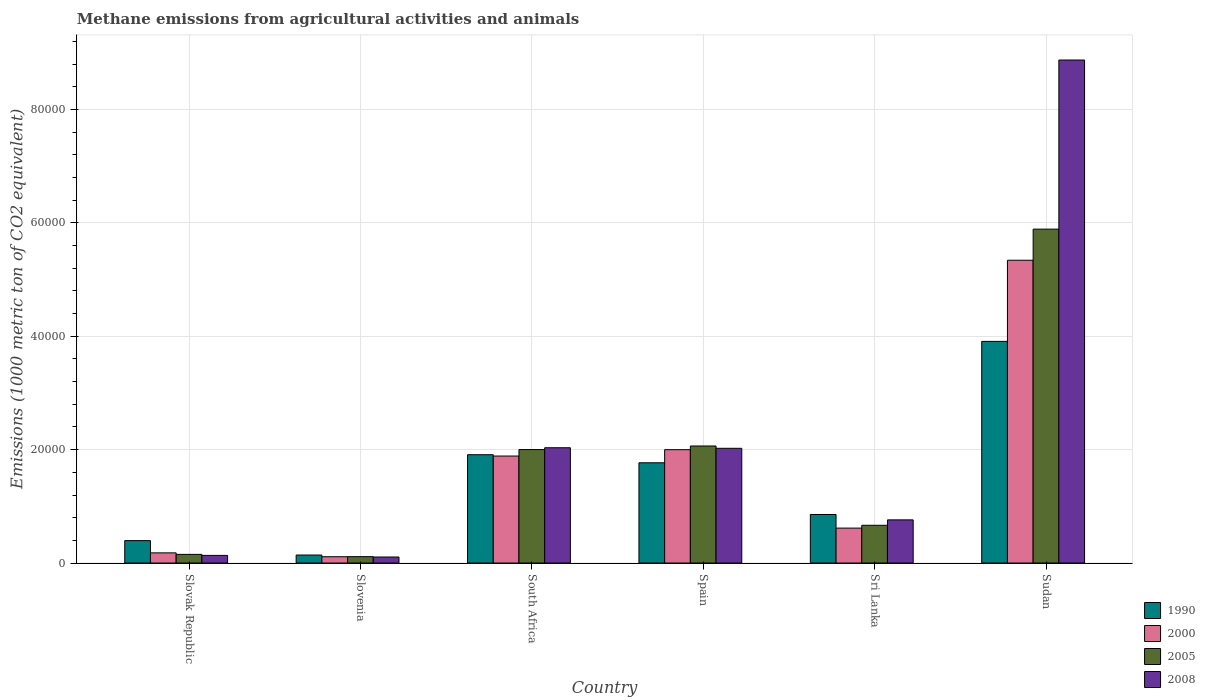Are the number of bars on each tick of the X-axis equal?
Give a very brief answer. Yes. What is the label of the 1st group of bars from the left?
Your answer should be compact. Slovak Republic. In how many cases, is the number of bars for a given country not equal to the number of legend labels?
Give a very brief answer. 0. What is the amount of methane emitted in 2005 in Slovak Republic?
Give a very brief answer. 1525.9. Across all countries, what is the maximum amount of methane emitted in 2005?
Ensure brevity in your answer.  5.89e+04. Across all countries, what is the minimum amount of methane emitted in 2005?
Your response must be concise. 1124.6. In which country was the amount of methane emitted in 2008 maximum?
Give a very brief answer. Sudan. In which country was the amount of methane emitted in 1990 minimum?
Your response must be concise. Slovenia. What is the total amount of methane emitted in 2005 in the graph?
Ensure brevity in your answer.  1.09e+05. What is the difference between the amount of methane emitted in 2000 in Sri Lanka and that in Sudan?
Your response must be concise. -4.73e+04. What is the difference between the amount of methane emitted in 2008 in Slovak Republic and the amount of methane emitted in 2005 in Spain?
Keep it short and to the point. -1.93e+04. What is the average amount of methane emitted in 2000 per country?
Your response must be concise. 1.69e+04. What is the difference between the amount of methane emitted of/in 1990 and amount of methane emitted of/in 2005 in Slovenia?
Provide a succinct answer. 288.9. What is the ratio of the amount of methane emitted in 1990 in Slovak Republic to that in Spain?
Your answer should be very brief. 0.22. Is the amount of methane emitted in 2005 in South Africa less than that in Sudan?
Keep it short and to the point. Yes. What is the difference between the highest and the second highest amount of methane emitted in 2008?
Offer a terse response. 99.4. What is the difference between the highest and the lowest amount of methane emitted in 2008?
Offer a terse response. 8.77e+04. Is it the case that in every country, the sum of the amount of methane emitted in 1990 and amount of methane emitted in 2000 is greater than the sum of amount of methane emitted in 2005 and amount of methane emitted in 2008?
Make the answer very short. No. How many bars are there?
Offer a terse response. 24. Are all the bars in the graph horizontal?
Ensure brevity in your answer.  No. Does the graph contain any zero values?
Provide a short and direct response. No. Does the graph contain grids?
Offer a terse response. Yes. How many legend labels are there?
Give a very brief answer. 4. What is the title of the graph?
Ensure brevity in your answer.  Methane emissions from agricultural activities and animals. What is the label or title of the X-axis?
Provide a succinct answer. Country. What is the label or title of the Y-axis?
Make the answer very short. Emissions (1000 metric ton of CO2 equivalent). What is the Emissions (1000 metric ton of CO2 equivalent) of 1990 in Slovak Republic?
Give a very brief answer. 3954.5. What is the Emissions (1000 metric ton of CO2 equivalent) in 2000 in Slovak Republic?
Offer a terse response. 1793.2. What is the Emissions (1000 metric ton of CO2 equivalent) in 2005 in Slovak Republic?
Your response must be concise. 1525.9. What is the Emissions (1000 metric ton of CO2 equivalent) in 2008 in Slovak Republic?
Offer a terse response. 1345.7. What is the Emissions (1000 metric ton of CO2 equivalent) of 1990 in Slovenia?
Your answer should be very brief. 1413.5. What is the Emissions (1000 metric ton of CO2 equivalent) of 2000 in Slovenia?
Your response must be concise. 1111. What is the Emissions (1000 metric ton of CO2 equivalent) of 2005 in Slovenia?
Make the answer very short. 1124.6. What is the Emissions (1000 metric ton of CO2 equivalent) in 2008 in Slovenia?
Give a very brief answer. 1061.8. What is the Emissions (1000 metric ton of CO2 equivalent) of 1990 in South Africa?
Keep it short and to the point. 1.91e+04. What is the Emissions (1000 metric ton of CO2 equivalent) of 2000 in South Africa?
Your answer should be compact. 1.89e+04. What is the Emissions (1000 metric ton of CO2 equivalent) of 2005 in South Africa?
Make the answer very short. 2.00e+04. What is the Emissions (1000 metric ton of CO2 equivalent) in 2008 in South Africa?
Your response must be concise. 2.03e+04. What is the Emissions (1000 metric ton of CO2 equivalent) in 1990 in Spain?
Offer a very short reply. 1.77e+04. What is the Emissions (1000 metric ton of CO2 equivalent) of 2000 in Spain?
Make the answer very short. 2.00e+04. What is the Emissions (1000 metric ton of CO2 equivalent) of 2005 in Spain?
Your response must be concise. 2.06e+04. What is the Emissions (1000 metric ton of CO2 equivalent) in 2008 in Spain?
Make the answer very short. 2.02e+04. What is the Emissions (1000 metric ton of CO2 equivalent) of 1990 in Sri Lanka?
Keep it short and to the point. 8565.4. What is the Emissions (1000 metric ton of CO2 equivalent) in 2000 in Sri Lanka?
Offer a terse response. 6161. What is the Emissions (1000 metric ton of CO2 equivalent) of 2005 in Sri Lanka?
Your answer should be very brief. 6658.4. What is the Emissions (1000 metric ton of CO2 equivalent) of 2008 in Sri Lanka?
Your response must be concise. 7614.5. What is the Emissions (1000 metric ton of CO2 equivalent) in 1990 in Sudan?
Your answer should be compact. 3.91e+04. What is the Emissions (1000 metric ton of CO2 equivalent) in 2000 in Sudan?
Provide a succinct answer. 5.34e+04. What is the Emissions (1000 metric ton of CO2 equivalent) in 2005 in Sudan?
Offer a very short reply. 5.89e+04. What is the Emissions (1000 metric ton of CO2 equivalent) in 2008 in Sudan?
Ensure brevity in your answer.  8.87e+04. Across all countries, what is the maximum Emissions (1000 metric ton of CO2 equivalent) of 1990?
Provide a succinct answer. 3.91e+04. Across all countries, what is the maximum Emissions (1000 metric ton of CO2 equivalent) in 2000?
Give a very brief answer. 5.34e+04. Across all countries, what is the maximum Emissions (1000 metric ton of CO2 equivalent) of 2005?
Provide a short and direct response. 5.89e+04. Across all countries, what is the maximum Emissions (1000 metric ton of CO2 equivalent) in 2008?
Provide a succinct answer. 8.87e+04. Across all countries, what is the minimum Emissions (1000 metric ton of CO2 equivalent) of 1990?
Offer a very short reply. 1413.5. Across all countries, what is the minimum Emissions (1000 metric ton of CO2 equivalent) of 2000?
Your answer should be very brief. 1111. Across all countries, what is the minimum Emissions (1000 metric ton of CO2 equivalent) in 2005?
Give a very brief answer. 1124.6. Across all countries, what is the minimum Emissions (1000 metric ton of CO2 equivalent) in 2008?
Your answer should be compact. 1061.8. What is the total Emissions (1000 metric ton of CO2 equivalent) of 1990 in the graph?
Provide a short and direct response. 8.98e+04. What is the total Emissions (1000 metric ton of CO2 equivalent) of 2000 in the graph?
Your answer should be very brief. 1.01e+05. What is the total Emissions (1000 metric ton of CO2 equivalent) of 2005 in the graph?
Ensure brevity in your answer.  1.09e+05. What is the total Emissions (1000 metric ton of CO2 equivalent) in 2008 in the graph?
Your answer should be very brief. 1.39e+05. What is the difference between the Emissions (1000 metric ton of CO2 equivalent) of 1990 in Slovak Republic and that in Slovenia?
Your response must be concise. 2541. What is the difference between the Emissions (1000 metric ton of CO2 equivalent) of 2000 in Slovak Republic and that in Slovenia?
Your response must be concise. 682.2. What is the difference between the Emissions (1000 metric ton of CO2 equivalent) in 2005 in Slovak Republic and that in Slovenia?
Offer a terse response. 401.3. What is the difference between the Emissions (1000 metric ton of CO2 equivalent) of 2008 in Slovak Republic and that in Slovenia?
Your answer should be compact. 283.9. What is the difference between the Emissions (1000 metric ton of CO2 equivalent) of 1990 in Slovak Republic and that in South Africa?
Provide a succinct answer. -1.52e+04. What is the difference between the Emissions (1000 metric ton of CO2 equivalent) of 2000 in Slovak Republic and that in South Africa?
Your answer should be compact. -1.71e+04. What is the difference between the Emissions (1000 metric ton of CO2 equivalent) of 2005 in Slovak Republic and that in South Africa?
Provide a succinct answer. -1.85e+04. What is the difference between the Emissions (1000 metric ton of CO2 equivalent) in 2008 in Slovak Republic and that in South Africa?
Keep it short and to the point. -1.90e+04. What is the difference between the Emissions (1000 metric ton of CO2 equivalent) in 1990 in Slovak Republic and that in Spain?
Your answer should be compact. -1.37e+04. What is the difference between the Emissions (1000 metric ton of CO2 equivalent) in 2000 in Slovak Republic and that in Spain?
Provide a succinct answer. -1.82e+04. What is the difference between the Emissions (1000 metric ton of CO2 equivalent) in 2005 in Slovak Republic and that in Spain?
Keep it short and to the point. -1.91e+04. What is the difference between the Emissions (1000 metric ton of CO2 equivalent) of 2008 in Slovak Republic and that in Spain?
Make the answer very short. -1.89e+04. What is the difference between the Emissions (1000 metric ton of CO2 equivalent) in 1990 in Slovak Republic and that in Sri Lanka?
Offer a very short reply. -4610.9. What is the difference between the Emissions (1000 metric ton of CO2 equivalent) of 2000 in Slovak Republic and that in Sri Lanka?
Give a very brief answer. -4367.8. What is the difference between the Emissions (1000 metric ton of CO2 equivalent) in 2005 in Slovak Republic and that in Sri Lanka?
Give a very brief answer. -5132.5. What is the difference between the Emissions (1000 metric ton of CO2 equivalent) in 2008 in Slovak Republic and that in Sri Lanka?
Your response must be concise. -6268.8. What is the difference between the Emissions (1000 metric ton of CO2 equivalent) of 1990 in Slovak Republic and that in Sudan?
Provide a short and direct response. -3.51e+04. What is the difference between the Emissions (1000 metric ton of CO2 equivalent) of 2000 in Slovak Republic and that in Sudan?
Your response must be concise. -5.16e+04. What is the difference between the Emissions (1000 metric ton of CO2 equivalent) in 2005 in Slovak Republic and that in Sudan?
Provide a short and direct response. -5.74e+04. What is the difference between the Emissions (1000 metric ton of CO2 equivalent) of 2008 in Slovak Republic and that in Sudan?
Give a very brief answer. -8.74e+04. What is the difference between the Emissions (1000 metric ton of CO2 equivalent) in 1990 in Slovenia and that in South Africa?
Keep it short and to the point. -1.77e+04. What is the difference between the Emissions (1000 metric ton of CO2 equivalent) of 2000 in Slovenia and that in South Africa?
Provide a succinct answer. -1.78e+04. What is the difference between the Emissions (1000 metric ton of CO2 equivalent) of 2005 in Slovenia and that in South Africa?
Provide a short and direct response. -1.89e+04. What is the difference between the Emissions (1000 metric ton of CO2 equivalent) in 2008 in Slovenia and that in South Africa?
Give a very brief answer. -1.93e+04. What is the difference between the Emissions (1000 metric ton of CO2 equivalent) of 1990 in Slovenia and that in Spain?
Provide a succinct answer. -1.63e+04. What is the difference between the Emissions (1000 metric ton of CO2 equivalent) of 2000 in Slovenia and that in Spain?
Make the answer very short. -1.89e+04. What is the difference between the Emissions (1000 metric ton of CO2 equivalent) of 2005 in Slovenia and that in Spain?
Make the answer very short. -1.95e+04. What is the difference between the Emissions (1000 metric ton of CO2 equivalent) in 2008 in Slovenia and that in Spain?
Give a very brief answer. -1.92e+04. What is the difference between the Emissions (1000 metric ton of CO2 equivalent) of 1990 in Slovenia and that in Sri Lanka?
Your answer should be compact. -7151.9. What is the difference between the Emissions (1000 metric ton of CO2 equivalent) of 2000 in Slovenia and that in Sri Lanka?
Give a very brief answer. -5050. What is the difference between the Emissions (1000 metric ton of CO2 equivalent) of 2005 in Slovenia and that in Sri Lanka?
Make the answer very short. -5533.8. What is the difference between the Emissions (1000 metric ton of CO2 equivalent) in 2008 in Slovenia and that in Sri Lanka?
Ensure brevity in your answer.  -6552.7. What is the difference between the Emissions (1000 metric ton of CO2 equivalent) of 1990 in Slovenia and that in Sudan?
Ensure brevity in your answer.  -3.77e+04. What is the difference between the Emissions (1000 metric ton of CO2 equivalent) of 2000 in Slovenia and that in Sudan?
Keep it short and to the point. -5.23e+04. What is the difference between the Emissions (1000 metric ton of CO2 equivalent) in 2005 in Slovenia and that in Sudan?
Your answer should be very brief. -5.78e+04. What is the difference between the Emissions (1000 metric ton of CO2 equivalent) in 2008 in Slovenia and that in Sudan?
Make the answer very short. -8.77e+04. What is the difference between the Emissions (1000 metric ton of CO2 equivalent) in 1990 in South Africa and that in Spain?
Keep it short and to the point. 1425.6. What is the difference between the Emissions (1000 metric ton of CO2 equivalent) in 2000 in South Africa and that in Spain?
Provide a short and direct response. -1123.1. What is the difference between the Emissions (1000 metric ton of CO2 equivalent) of 2005 in South Africa and that in Spain?
Give a very brief answer. -632.9. What is the difference between the Emissions (1000 metric ton of CO2 equivalent) in 2008 in South Africa and that in Spain?
Your answer should be compact. 99.4. What is the difference between the Emissions (1000 metric ton of CO2 equivalent) of 1990 in South Africa and that in Sri Lanka?
Ensure brevity in your answer.  1.05e+04. What is the difference between the Emissions (1000 metric ton of CO2 equivalent) in 2000 in South Africa and that in Sri Lanka?
Offer a very short reply. 1.27e+04. What is the difference between the Emissions (1000 metric ton of CO2 equivalent) in 2005 in South Africa and that in Sri Lanka?
Offer a terse response. 1.34e+04. What is the difference between the Emissions (1000 metric ton of CO2 equivalent) in 2008 in South Africa and that in Sri Lanka?
Make the answer very short. 1.27e+04. What is the difference between the Emissions (1000 metric ton of CO2 equivalent) in 1990 in South Africa and that in Sudan?
Keep it short and to the point. -2.00e+04. What is the difference between the Emissions (1000 metric ton of CO2 equivalent) of 2000 in South Africa and that in Sudan?
Offer a terse response. -3.45e+04. What is the difference between the Emissions (1000 metric ton of CO2 equivalent) of 2005 in South Africa and that in Sudan?
Provide a succinct answer. -3.89e+04. What is the difference between the Emissions (1000 metric ton of CO2 equivalent) of 2008 in South Africa and that in Sudan?
Make the answer very short. -6.84e+04. What is the difference between the Emissions (1000 metric ton of CO2 equivalent) in 1990 in Spain and that in Sri Lanka?
Make the answer very short. 9117.2. What is the difference between the Emissions (1000 metric ton of CO2 equivalent) of 2000 in Spain and that in Sri Lanka?
Your response must be concise. 1.38e+04. What is the difference between the Emissions (1000 metric ton of CO2 equivalent) in 2005 in Spain and that in Sri Lanka?
Your response must be concise. 1.40e+04. What is the difference between the Emissions (1000 metric ton of CO2 equivalent) of 2008 in Spain and that in Sri Lanka?
Provide a short and direct response. 1.26e+04. What is the difference between the Emissions (1000 metric ton of CO2 equivalent) of 1990 in Spain and that in Sudan?
Make the answer very short. -2.14e+04. What is the difference between the Emissions (1000 metric ton of CO2 equivalent) in 2000 in Spain and that in Sudan?
Keep it short and to the point. -3.34e+04. What is the difference between the Emissions (1000 metric ton of CO2 equivalent) of 2005 in Spain and that in Sudan?
Provide a succinct answer. -3.83e+04. What is the difference between the Emissions (1000 metric ton of CO2 equivalent) in 2008 in Spain and that in Sudan?
Make the answer very short. -6.85e+04. What is the difference between the Emissions (1000 metric ton of CO2 equivalent) in 1990 in Sri Lanka and that in Sudan?
Your answer should be very brief. -3.05e+04. What is the difference between the Emissions (1000 metric ton of CO2 equivalent) of 2000 in Sri Lanka and that in Sudan?
Your answer should be very brief. -4.73e+04. What is the difference between the Emissions (1000 metric ton of CO2 equivalent) of 2005 in Sri Lanka and that in Sudan?
Your answer should be compact. -5.22e+04. What is the difference between the Emissions (1000 metric ton of CO2 equivalent) of 2008 in Sri Lanka and that in Sudan?
Provide a succinct answer. -8.11e+04. What is the difference between the Emissions (1000 metric ton of CO2 equivalent) of 1990 in Slovak Republic and the Emissions (1000 metric ton of CO2 equivalent) of 2000 in Slovenia?
Make the answer very short. 2843.5. What is the difference between the Emissions (1000 metric ton of CO2 equivalent) of 1990 in Slovak Republic and the Emissions (1000 metric ton of CO2 equivalent) of 2005 in Slovenia?
Give a very brief answer. 2829.9. What is the difference between the Emissions (1000 metric ton of CO2 equivalent) in 1990 in Slovak Republic and the Emissions (1000 metric ton of CO2 equivalent) in 2008 in Slovenia?
Make the answer very short. 2892.7. What is the difference between the Emissions (1000 metric ton of CO2 equivalent) in 2000 in Slovak Republic and the Emissions (1000 metric ton of CO2 equivalent) in 2005 in Slovenia?
Make the answer very short. 668.6. What is the difference between the Emissions (1000 metric ton of CO2 equivalent) in 2000 in Slovak Republic and the Emissions (1000 metric ton of CO2 equivalent) in 2008 in Slovenia?
Offer a terse response. 731.4. What is the difference between the Emissions (1000 metric ton of CO2 equivalent) of 2005 in Slovak Republic and the Emissions (1000 metric ton of CO2 equivalent) of 2008 in Slovenia?
Make the answer very short. 464.1. What is the difference between the Emissions (1000 metric ton of CO2 equivalent) of 1990 in Slovak Republic and the Emissions (1000 metric ton of CO2 equivalent) of 2000 in South Africa?
Your response must be concise. -1.49e+04. What is the difference between the Emissions (1000 metric ton of CO2 equivalent) of 1990 in Slovak Republic and the Emissions (1000 metric ton of CO2 equivalent) of 2005 in South Africa?
Provide a short and direct response. -1.61e+04. What is the difference between the Emissions (1000 metric ton of CO2 equivalent) of 1990 in Slovak Republic and the Emissions (1000 metric ton of CO2 equivalent) of 2008 in South Africa?
Give a very brief answer. -1.64e+04. What is the difference between the Emissions (1000 metric ton of CO2 equivalent) of 2000 in Slovak Republic and the Emissions (1000 metric ton of CO2 equivalent) of 2005 in South Africa?
Your response must be concise. -1.82e+04. What is the difference between the Emissions (1000 metric ton of CO2 equivalent) in 2000 in Slovak Republic and the Emissions (1000 metric ton of CO2 equivalent) in 2008 in South Africa?
Make the answer very short. -1.85e+04. What is the difference between the Emissions (1000 metric ton of CO2 equivalent) in 2005 in Slovak Republic and the Emissions (1000 metric ton of CO2 equivalent) in 2008 in South Africa?
Provide a succinct answer. -1.88e+04. What is the difference between the Emissions (1000 metric ton of CO2 equivalent) in 1990 in Slovak Republic and the Emissions (1000 metric ton of CO2 equivalent) in 2000 in Spain?
Provide a succinct answer. -1.60e+04. What is the difference between the Emissions (1000 metric ton of CO2 equivalent) of 1990 in Slovak Republic and the Emissions (1000 metric ton of CO2 equivalent) of 2005 in Spain?
Provide a short and direct response. -1.67e+04. What is the difference between the Emissions (1000 metric ton of CO2 equivalent) of 1990 in Slovak Republic and the Emissions (1000 metric ton of CO2 equivalent) of 2008 in Spain?
Your answer should be compact. -1.63e+04. What is the difference between the Emissions (1000 metric ton of CO2 equivalent) in 2000 in Slovak Republic and the Emissions (1000 metric ton of CO2 equivalent) in 2005 in Spain?
Your response must be concise. -1.89e+04. What is the difference between the Emissions (1000 metric ton of CO2 equivalent) of 2000 in Slovak Republic and the Emissions (1000 metric ton of CO2 equivalent) of 2008 in Spain?
Your answer should be compact. -1.84e+04. What is the difference between the Emissions (1000 metric ton of CO2 equivalent) of 2005 in Slovak Republic and the Emissions (1000 metric ton of CO2 equivalent) of 2008 in Spain?
Provide a short and direct response. -1.87e+04. What is the difference between the Emissions (1000 metric ton of CO2 equivalent) of 1990 in Slovak Republic and the Emissions (1000 metric ton of CO2 equivalent) of 2000 in Sri Lanka?
Offer a very short reply. -2206.5. What is the difference between the Emissions (1000 metric ton of CO2 equivalent) in 1990 in Slovak Republic and the Emissions (1000 metric ton of CO2 equivalent) in 2005 in Sri Lanka?
Offer a terse response. -2703.9. What is the difference between the Emissions (1000 metric ton of CO2 equivalent) of 1990 in Slovak Republic and the Emissions (1000 metric ton of CO2 equivalent) of 2008 in Sri Lanka?
Your response must be concise. -3660. What is the difference between the Emissions (1000 metric ton of CO2 equivalent) of 2000 in Slovak Republic and the Emissions (1000 metric ton of CO2 equivalent) of 2005 in Sri Lanka?
Provide a succinct answer. -4865.2. What is the difference between the Emissions (1000 metric ton of CO2 equivalent) of 2000 in Slovak Republic and the Emissions (1000 metric ton of CO2 equivalent) of 2008 in Sri Lanka?
Provide a short and direct response. -5821.3. What is the difference between the Emissions (1000 metric ton of CO2 equivalent) in 2005 in Slovak Republic and the Emissions (1000 metric ton of CO2 equivalent) in 2008 in Sri Lanka?
Offer a terse response. -6088.6. What is the difference between the Emissions (1000 metric ton of CO2 equivalent) of 1990 in Slovak Republic and the Emissions (1000 metric ton of CO2 equivalent) of 2000 in Sudan?
Give a very brief answer. -4.95e+04. What is the difference between the Emissions (1000 metric ton of CO2 equivalent) of 1990 in Slovak Republic and the Emissions (1000 metric ton of CO2 equivalent) of 2005 in Sudan?
Provide a succinct answer. -5.49e+04. What is the difference between the Emissions (1000 metric ton of CO2 equivalent) of 1990 in Slovak Republic and the Emissions (1000 metric ton of CO2 equivalent) of 2008 in Sudan?
Your response must be concise. -8.48e+04. What is the difference between the Emissions (1000 metric ton of CO2 equivalent) in 2000 in Slovak Republic and the Emissions (1000 metric ton of CO2 equivalent) in 2005 in Sudan?
Your response must be concise. -5.71e+04. What is the difference between the Emissions (1000 metric ton of CO2 equivalent) of 2000 in Slovak Republic and the Emissions (1000 metric ton of CO2 equivalent) of 2008 in Sudan?
Keep it short and to the point. -8.69e+04. What is the difference between the Emissions (1000 metric ton of CO2 equivalent) of 2005 in Slovak Republic and the Emissions (1000 metric ton of CO2 equivalent) of 2008 in Sudan?
Keep it short and to the point. -8.72e+04. What is the difference between the Emissions (1000 metric ton of CO2 equivalent) of 1990 in Slovenia and the Emissions (1000 metric ton of CO2 equivalent) of 2000 in South Africa?
Provide a succinct answer. -1.75e+04. What is the difference between the Emissions (1000 metric ton of CO2 equivalent) in 1990 in Slovenia and the Emissions (1000 metric ton of CO2 equivalent) in 2005 in South Africa?
Your answer should be compact. -1.86e+04. What is the difference between the Emissions (1000 metric ton of CO2 equivalent) of 1990 in Slovenia and the Emissions (1000 metric ton of CO2 equivalent) of 2008 in South Africa?
Your answer should be compact. -1.89e+04. What is the difference between the Emissions (1000 metric ton of CO2 equivalent) of 2000 in Slovenia and the Emissions (1000 metric ton of CO2 equivalent) of 2005 in South Africa?
Your answer should be very brief. -1.89e+04. What is the difference between the Emissions (1000 metric ton of CO2 equivalent) in 2000 in Slovenia and the Emissions (1000 metric ton of CO2 equivalent) in 2008 in South Africa?
Your answer should be compact. -1.92e+04. What is the difference between the Emissions (1000 metric ton of CO2 equivalent) of 2005 in Slovenia and the Emissions (1000 metric ton of CO2 equivalent) of 2008 in South Africa?
Give a very brief answer. -1.92e+04. What is the difference between the Emissions (1000 metric ton of CO2 equivalent) in 1990 in Slovenia and the Emissions (1000 metric ton of CO2 equivalent) in 2000 in Spain?
Ensure brevity in your answer.  -1.86e+04. What is the difference between the Emissions (1000 metric ton of CO2 equivalent) of 1990 in Slovenia and the Emissions (1000 metric ton of CO2 equivalent) of 2005 in Spain?
Your response must be concise. -1.92e+04. What is the difference between the Emissions (1000 metric ton of CO2 equivalent) in 1990 in Slovenia and the Emissions (1000 metric ton of CO2 equivalent) in 2008 in Spain?
Keep it short and to the point. -1.88e+04. What is the difference between the Emissions (1000 metric ton of CO2 equivalent) of 2000 in Slovenia and the Emissions (1000 metric ton of CO2 equivalent) of 2005 in Spain?
Provide a short and direct response. -1.95e+04. What is the difference between the Emissions (1000 metric ton of CO2 equivalent) in 2000 in Slovenia and the Emissions (1000 metric ton of CO2 equivalent) in 2008 in Spain?
Provide a short and direct response. -1.91e+04. What is the difference between the Emissions (1000 metric ton of CO2 equivalent) of 2005 in Slovenia and the Emissions (1000 metric ton of CO2 equivalent) of 2008 in Spain?
Your answer should be compact. -1.91e+04. What is the difference between the Emissions (1000 metric ton of CO2 equivalent) in 1990 in Slovenia and the Emissions (1000 metric ton of CO2 equivalent) in 2000 in Sri Lanka?
Your response must be concise. -4747.5. What is the difference between the Emissions (1000 metric ton of CO2 equivalent) of 1990 in Slovenia and the Emissions (1000 metric ton of CO2 equivalent) of 2005 in Sri Lanka?
Offer a very short reply. -5244.9. What is the difference between the Emissions (1000 metric ton of CO2 equivalent) of 1990 in Slovenia and the Emissions (1000 metric ton of CO2 equivalent) of 2008 in Sri Lanka?
Make the answer very short. -6201. What is the difference between the Emissions (1000 metric ton of CO2 equivalent) of 2000 in Slovenia and the Emissions (1000 metric ton of CO2 equivalent) of 2005 in Sri Lanka?
Offer a very short reply. -5547.4. What is the difference between the Emissions (1000 metric ton of CO2 equivalent) in 2000 in Slovenia and the Emissions (1000 metric ton of CO2 equivalent) in 2008 in Sri Lanka?
Offer a terse response. -6503.5. What is the difference between the Emissions (1000 metric ton of CO2 equivalent) in 2005 in Slovenia and the Emissions (1000 metric ton of CO2 equivalent) in 2008 in Sri Lanka?
Offer a very short reply. -6489.9. What is the difference between the Emissions (1000 metric ton of CO2 equivalent) in 1990 in Slovenia and the Emissions (1000 metric ton of CO2 equivalent) in 2000 in Sudan?
Your response must be concise. -5.20e+04. What is the difference between the Emissions (1000 metric ton of CO2 equivalent) in 1990 in Slovenia and the Emissions (1000 metric ton of CO2 equivalent) in 2005 in Sudan?
Offer a terse response. -5.75e+04. What is the difference between the Emissions (1000 metric ton of CO2 equivalent) in 1990 in Slovenia and the Emissions (1000 metric ton of CO2 equivalent) in 2008 in Sudan?
Keep it short and to the point. -8.73e+04. What is the difference between the Emissions (1000 metric ton of CO2 equivalent) of 2000 in Slovenia and the Emissions (1000 metric ton of CO2 equivalent) of 2005 in Sudan?
Make the answer very short. -5.78e+04. What is the difference between the Emissions (1000 metric ton of CO2 equivalent) of 2000 in Slovenia and the Emissions (1000 metric ton of CO2 equivalent) of 2008 in Sudan?
Offer a terse response. -8.76e+04. What is the difference between the Emissions (1000 metric ton of CO2 equivalent) in 2005 in Slovenia and the Emissions (1000 metric ton of CO2 equivalent) in 2008 in Sudan?
Provide a short and direct response. -8.76e+04. What is the difference between the Emissions (1000 metric ton of CO2 equivalent) in 1990 in South Africa and the Emissions (1000 metric ton of CO2 equivalent) in 2000 in Spain?
Keep it short and to the point. -888.5. What is the difference between the Emissions (1000 metric ton of CO2 equivalent) in 1990 in South Africa and the Emissions (1000 metric ton of CO2 equivalent) in 2005 in Spain?
Your response must be concise. -1539.2. What is the difference between the Emissions (1000 metric ton of CO2 equivalent) of 1990 in South Africa and the Emissions (1000 metric ton of CO2 equivalent) of 2008 in Spain?
Ensure brevity in your answer.  -1130.3. What is the difference between the Emissions (1000 metric ton of CO2 equivalent) in 2000 in South Africa and the Emissions (1000 metric ton of CO2 equivalent) in 2005 in Spain?
Your answer should be very brief. -1773.8. What is the difference between the Emissions (1000 metric ton of CO2 equivalent) of 2000 in South Africa and the Emissions (1000 metric ton of CO2 equivalent) of 2008 in Spain?
Provide a succinct answer. -1364.9. What is the difference between the Emissions (1000 metric ton of CO2 equivalent) of 2005 in South Africa and the Emissions (1000 metric ton of CO2 equivalent) of 2008 in Spain?
Your answer should be compact. -224. What is the difference between the Emissions (1000 metric ton of CO2 equivalent) in 1990 in South Africa and the Emissions (1000 metric ton of CO2 equivalent) in 2000 in Sri Lanka?
Offer a very short reply. 1.29e+04. What is the difference between the Emissions (1000 metric ton of CO2 equivalent) of 1990 in South Africa and the Emissions (1000 metric ton of CO2 equivalent) of 2005 in Sri Lanka?
Your answer should be very brief. 1.24e+04. What is the difference between the Emissions (1000 metric ton of CO2 equivalent) of 1990 in South Africa and the Emissions (1000 metric ton of CO2 equivalent) of 2008 in Sri Lanka?
Make the answer very short. 1.15e+04. What is the difference between the Emissions (1000 metric ton of CO2 equivalent) in 2000 in South Africa and the Emissions (1000 metric ton of CO2 equivalent) in 2005 in Sri Lanka?
Your response must be concise. 1.22e+04. What is the difference between the Emissions (1000 metric ton of CO2 equivalent) in 2000 in South Africa and the Emissions (1000 metric ton of CO2 equivalent) in 2008 in Sri Lanka?
Give a very brief answer. 1.13e+04. What is the difference between the Emissions (1000 metric ton of CO2 equivalent) in 2005 in South Africa and the Emissions (1000 metric ton of CO2 equivalent) in 2008 in Sri Lanka?
Offer a very short reply. 1.24e+04. What is the difference between the Emissions (1000 metric ton of CO2 equivalent) in 1990 in South Africa and the Emissions (1000 metric ton of CO2 equivalent) in 2000 in Sudan?
Keep it short and to the point. -3.43e+04. What is the difference between the Emissions (1000 metric ton of CO2 equivalent) of 1990 in South Africa and the Emissions (1000 metric ton of CO2 equivalent) of 2005 in Sudan?
Ensure brevity in your answer.  -3.98e+04. What is the difference between the Emissions (1000 metric ton of CO2 equivalent) in 1990 in South Africa and the Emissions (1000 metric ton of CO2 equivalent) in 2008 in Sudan?
Your answer should be compact. -6.96e+04. What is the difference between the Emissions (1000 metric ton of CO2 equivalent) in 2000 in South Africa and the Emissions (1000 metric ton of CO2 equivalent) in 2005 in Sudan?
Your answer should be compact. -4.00e+04. What is the difference between the Emissions (1000 metric ton of CO2 equivalent) in 2000 in South Africa and the Emissions (1000 metric ton of CO2 equivalent) in 2008 in Sudan?
Keep it short and to the point. -6.99e+04. What is the difference between the Emissions (1000 metric ton of CO2 equivalent) in 2005 in South Africa and the Emissions (1000 metric ton of CO2 equivalent) in 2008 in Sudan?
Offer a terse response. -6.87e+04. What is the difference between the Emissions (1000 metric ton of CO2 equivalent) of 1990 in Spain and the Emissions (1000 metric ton of CO2 equivalent) of 2000 in Sri Lanka?
Give a very brief answer. 1.15e+04. What is the difference between the Emissions (1000 metric ton of CO2 equivalent) of 1990 in Spain and the Emissions (1000 metric ton of CO2 equivalent) of 2005 in Sri Lanka?
Keep it short and to the point. 1.10e+04. What is the difference between the Emissions (1000 metric ton of CO2 equivalent) of 1990 in Spain and the Emissions (1000 metric ton of CO2 equivalent) of 2008 in Sri Lanka?
Make the answer very short. 1.01e+04. What is the difference between the Emissions (1000 metric ton of CO2 equivalent) of 2000 in Spain and the Emissions (1000 metric ton of CO2 equivalent) of 2005 in Sri Lanka?
Make the answer very short. 1.33e+04. What is the difference between the Emissions (1000 metric ton of CO2 equivalent) in 2000 in Spain and the Emissions (1000 metric ton of CO2 equivalent) in 2008 in Sri Lanka?
Offer a terse response. 1.24e+04. What is the difference between the Emissions (1000 metric ton of CO2 equivalent) of 2005 in Spain and the Emissions (1000 metric ton of CO2 equivalent) of 2008 in Sri Lanka?
Your answer should be very brief. 1.30e+04. What is the difference between the Emissions (1000 metric ton of CO2 equivalent) of 1990 in Spain and the Emissions (1000 metric ton of CO2 equivalent) of 2000 in Sudan?
Offer a very short reply. -3.57e+04. What is the difference between the Emissions (1000 metric ton of CO2 equivalent) of 1990 in Spain and the Emissions (1000 metric ton of CO2 equivalent) of 2005 in Sudan?
Provide a succinct answer. -4.12e+04. What is the difference between the Emissions (1000 metric ton of CO2 equivalent) of 1990 in Spain and the Emissions (1000 metric ton of CO2 equivalent) of 2008 in Sudan?
Provide a short and direct response. -7.11e+04. What is the difference between the Emissions (1000 metric ton of CO2 equivalent) in 2000 in Spain and the Emissions (1000 metric ton of CO2 equivalent) in 2005 in Sudan?
Provide a short and direct response. -3.89e+04. What is the difference between the Emissions (1000 metric ton of CO2 equivalent) in 2000 in Spain and the Emissions (1000 metric ton of CO2 equivalent) in 2008 in Sudan?
Your answer should be very brief. -6.87e+04. What is the difference between the Emissions (1000 metric ton of CO2 equivalent) in 2005 in Spain and the Emissions (1000 metric ton of CO2 equivalent) in 2008 in Sudan?
Ensure brevity in your answer.  -6.81e+04. What is the difference between the Emissions (1000 metric ton of CO2 equivalent) of 1990 in Sri Lanka and the Emissions (1000 metric ton of CO2 equivalent) of 2000 in Sudan?
Offer a very short reply. -4.48e+04. What is the difference between the Emissions (1000 metric ton of CO2 equivalent) in 1990 in Sri Lanka and the Emissions (1000 metric ton of CO2 equivalent) in 2005 in Sudan?
Ensure brevity in your answer.  -5.03e+04. What is the difference between the Emissions (1000 metric ton of CO2 equivalent) in 1990 in Sri Lanka and the Emissions (1000 metric ton of CO2 equivalent) in 2008 in Sudan?
Provide a short and direct response. -8.02e+04. What is the difference between the Emissions (1000 metric ton of CO2 equivalent) of 2000 in Sri Lanka and the Emissions (1000 metric ton of CO2 equivalent) of 2005 in Sudan?
Provide a short and direct response. -5.27e+04. What is the difference between the Emissions (1000 metric ton of CO2 equivalent) in 2000 in Sri Lanka and the Emissions (1000 metric ton of CO2 equivalent) in 2008 in Sudan?
Your response must be concise. -8.26e+04. What is the difference between the Emissions (1000 metric ton of CO2 equivalent) in 2005 in Sri Lanka and the Emissions (1000 metric ton of CO2 equivalent) in 2008 in Sudan?
Give a very brief answer. -8.21e+04. What is the average Emissions (1000 metric ton of CO2 equivalent) of 1990 per country?
Make the answer very short. 1.50e+04. What is the average Emissions (1000 metric ton of CO2 equivalent) of 2000 per country?
Provide a succinct answer. 1.69e+04. What is the average Emissions (1000 metric ton of CO2 equivalent) in 2005 per country?
Provide a short and direct response. 1.81e+04. What is the average Emissions (1000 metric ton of CO2 equivalent) in 2008 per country?
Your answer should be very brief. 2.32e+04. What is the difference between the Emissions (1000 metric ton of CO2 equivalent) of 1990 and Emissions (1000 metric ton of CO2 equivalent) of 2000 in Slovak Republic?
Make the answer very short. 2161.3. What is the difference between the Emissions (1000 metric ton of CO2 equivalent) of 1990 and Emissions (1000 metric ton of CO2 equivalent) of 2005 in Slovak Republic?
Your response must be concise. 2428.6. What is the difference between the Emissions (1000 metric ton of CO2 equivalent) of 1990 and Emissions (1000 metric ton of CO2 equivalent) of 2008 in Slovak Republic?
Ensure brevity in your answer.  2608.8. What is the difference between the Emissions (1000 metric ton of CO2 equivalent) in 2000 and Emissions (1000 metric ton of CO2 equivalent) in 2005 in Slovak Republic?
Your answer should be very brief. 267.3. What is the difference between the Emissions (1000 metric ton of CO2 equivalent) in 2000 and Emissions (1000 metric ton of CO2 equivalent) in 2008 in Slovak Republic?
Make the answer very short. 447.5. What is the difference between the Emissions (1000 metric ton of CO2 equivalent) in 2005 and Emissions (1000 metric ton of CO2 equivalent) in 2008 in Slovak Republic?
Your answer should be compact. 180.2. What is the difference between the Emissions (1000 metric ton of CO2 equivalent) of 1990 and Emissions (1000 metric ton of CO2 equivalent) of 2000 in Slovenia?
Ensure brevity in your answer.  302.5. What is the difference between the Emissions (1000 metric ton of CO2 equivalent) in 1990 and Emissions (1000 metric ton of CO2 equivalent) in 2005 in Slovenia?
Make the answer very short. 288.9. What is the difference between the Emissions (1000 metric ton of CO2 equivalent) in 1990 and Emissions (1000 metric ton of CO2 equivalent) in 2008 in Slovenia?
Your answer should be very brief. 351.7. What is the difference between the Emissions (1000 metric ton of CO2 equivalent) of 2000 and Emissions (1000 metric ton of CO2 equivalent) of 2008 in Slovenia?
Your answer should be compact. 49.2. What is the difference between the Emissions (1000 metric ton of CO2 equivalent) in 2005 and Emissions (1000 metric ton of CO2 equivalent) in 2008 in Slovenia?
Provide a short and direct response. 62.8. What is the difference between the Emissions (1000 metric ton of CO2 equivalent) in 1990 and Emissions (1000 metric ton of CO2 equivalent) in 2000 in South Africa?
Offer a terse response. 234.6. What is the difference between the Emissions (1000 metric ton of CO2 equivalent) of 1990 and Emissions (1000 metric ton of CO2 equivalent) of 2005 in South Africa?
Give a very brief answer. -906.3. What is the difference between the Emissions (1000 metric ton of CO2 equivalent) of 1990 and Emissions (1000 metric ton of CO2 equivalent) of 2008 in South Africa?
Provide a short and direct response. -1229.7. What is the difference between the Emissions (1000 metric ton of CO2 equivalent) in 2000 and Emissions (1000 metric ton of CO2 equivalent) in 2005 in South Africa?
Keep it short and to the point. -1140.9. What is the difference between the Emissions (1000 metric ton of CO2 equivalent) in 2000 and Emissions (1000 metric ton of CO2 equivalent) in 2008 in South Africa?
Provide a succinct answer. -1464.3. What is the difference between the Emissions (1000 metric ton of CO2 equivalent) of 2005 and Emissions (1000 metric ton of CO2 equivalent) of 2008 in South Africa?
Ensure brevity in your answer.  -323.4. What is the difference between the Emissions (1000 metric ton of CO2 equivalent) in 1990 and Emissions (1000 metric ton of CO2 equivalent) in 2000 in Spain?
Make the answer very short. -2314.1. What is the difference between the Emissions (1000 metric ton of CO2 equivalent) in 1990 and Emissions (1000 metric ton of CO2 equivalent) in 2005 in Spain?
Provide a succinct answer. -2964.8. What is the difference between the Emissions (1000 metric ton of CO2 equivalent) in 1990 and Emissions (1000 metric ton of CO2 equivalent) in 2008 in Spain?
Provide a succinct answer. -2555.9. What is the difference between the Emissions (1000 metric ton of CO2 equivalent) in 2000 and Emissions (1000 metric ton of CO2 equivalent) in 2005 in Spain?
Your answer should be very brief. -650.7. What is the difference between the Emissions (1000 metric ton of CO2 equivalent) in 2000 and Emissions (1000 metric ton of CO2 equivalent) in 2008 in Spain?
Your response must be concise. -241.8. What is the difference between the Emissions (1000 metric ton of CO2 equivalent) in 2005 and Emissions (1000 metric ton of CO2 equivalent) in 2008 in Spain?
Your answer should be compact. 408.9. What is the difference between the Emissions (1000 metric ton of CO2 equivalent) of 1990 and Emissions (1000 metric ton of CO2 equivalent) of 2000 in Sri Lanka?
Offer a very short reply. 2404.4. What is the difference between the Emissions (1000 metric ton of CO2 equivalent) in 1990 and Emissions (1000 metric ton of CO2 equivalent) in 2005 in Sri Lanka?
Your answer should be compact. 1907. What is the difference between the Emissions (1000 metric ton of CO2 equivalent) in 1990 and Emissions (1000 metric ton of CO2 equivalent) in 2008 in Sri Lanka?
Offer a very short reply. 950.9. What is the difference between the Emissions (1000 metric ton of CO2 equivalent) of 2000 and Emissions (1000 metric ton of CO2 equivalent) of 2005 in Sri Lanka?
Provide a short and direct response. -497.4. What is the difference between the Emissions (1000 metric ton of CO2 equivalent) of 2000 and Emissions (1000 metric ton of CO2 equivalent) of 2008 in Sri Lanka?
Your answer should be compact. -1453.5. What is the difference between the Emissions (1000 metric ton of CO2 equivalent) of 2005 and Emissions (1000 metric ton of CO2 equivalent) of 2008 in Sri Lanka?
Keep it short and to the point. -956.1. What is the difference between the Emissions (1000 metric ton of CO2 equivalent) in 1990 and Emissions (1000 metric ton of CO2 equivalent) in 2000 in Sudan?
Offer a terse response. -1.43e+04. What is the difference between the Emissions (1000 metric ton of CO2 equivalent) of 1990 and Emissions (1000 metric ton of CO2 equivalent) of 2005 in Sudan?
Give a very brief answer. -1.98e+04. What is the difference between the Emissions (1000 metric ton of CO2 equivalent) in 1990 and Emissions (1000 metric ton of CO2 equivalent) in 2008 in Sudan?
Your answer should be very brief. -4.96e+04. What is the difference between the Emissions (1000 metric ton of CO2 equivalent) in 2000 and Emissions (1000 metric ton of CO2 equivalent) in 2005 in Sudan?
Your answer should be very brief. -5487.9. What is the difference between the Emissions (1000 metric ton of CO2 equivalent) in 2000 and Emissions (1000 metric ton of CO2 equivalent) in 2008 in Sudan?
Provide a succinct answer. -3.53e+04. What is the difference between the Emissions (1000 metric ton of CO2 equivalent) of 2005 and Emissions (1000 metric ton of CO2 equivalent) of 2008 in Sudan?
Your response must be concise. -2.98e+04. What is the ratio of the Emissions (1000 metric ton of CO2 equivalent) of 1990 in Slovak Republic to that in Slovenia?
Give a very brief answer. 2.8. What is the ratio of the Emissions (1000 metric ton of CO2 equivalent) in 2000 in Slovak Republic to that in Slovenia?
Offer a very short reply. 1.61. What is the ratio of the Emissions (1000 metric ton of CO2 equivalent) in 2005 in Slovak Republic to that in Slovenia?
Offer a terse response. 1.36. What is the ratio of the Emissions (1000 metric ton of CO2 equivalent) of 2008 in Slovak Republic to that in Slovenia?
Provide a short and direct response. 1.27. What is the ratio of the Emissions (1000 metric ton of CO2 equivalent) of 1990 in Slovak Republic to that in South Africa?
Your answer should be very brief. 0.21. What is the ratio of the Emissions (1000 metric ton of CO2 equivalent) in 2000 in Slovak Republic to that in South Africa?
Your answer should be compact. 0.1. What is the ratio of the Emissions (1000 metric ton of CO2 equivalent) in 2005 in Slovak Republic to that in South Africa?
Provide a short and direct response. 0.08. What is the ratio of the Emissions (1000 metric ton of CO2 equivalent) in 2008 in Slovak Republic to that in South Africa?
Offer a terse response. 0.07. What is the ratio of the Emissions (1000 metric ton of CO2 equivalent) in 1990 in Slovak Republic to that in Spain?
Keep it short and to the point. 0.22. What is the ratio of the Emissions (1000 metric ton of CO2 equivalent) of 2000 in Slovak Republic to that in Spain?
Give a very brief answer. 0.09. What is the ratio of the Emissions (1000 metric ton of CO2 equivalent) of 2005 in Slovak Republic to that in Spain?
Ensure brevity in your answer.  0.07. What is the ratio of the Emissions (1000 metric ton of CO2 equivalent) in 2008 in Slovak Republic to that in Spain?
Your answer should be compact. 0.07. What is the ratio of the Emissions (1000 metric ton of CO2 equivalent) of 1990 in Slovak Republic to that in Sri Lanka?
Your answer should be compact. 0.46. What is the ratio of the Emissions (1000 metric ton of CO2 equivalent) in 2000 in Slovak Republic to that in Sri Lanka?
Offer a very short reply. 0.29. What is the ratio of the Emissions (1000 metric ton of CO2 equivalent) in 2005 in Slovak Republic to that in Sri Lanka?
Offer a terse response. 0.23. What is the ratio of the Emissions (1000 metric ton of CO2 equivalent) in 2008 in Slovak Republic to that in Sri Lanka?
Give a very brief answer. 0.18. What is the ratio of the Emissions (1000 metric ton of CO2 equivalent) in 1990 in Slovak Republic to that in Sudan?
Your answer should be compact. 0.1. What is the ratio of the Emissions (1000 metric ton of CO2 equivalent) of 2000 in Slovak Republic to that in Sudan?
Provide a short and direct response. 0.03. What is the ratio of the Emissions (1000 metric ton of CO2 equivalent) of 2005 in Slovak Republic to that in Sudan?
Keep it short and to the point. 0.03. What is the ratio of the Emissions (1000 metric ton of CO2 equivalent) in 2008 in Slovak Republic to that in Sudan?
Provide a succinct answer. 0.02. What is the ratio of the Emissions (1000 metric ton of CO2 equivalent) in 1990 in Slovenia to that in South Africa?
Ensure brevity in your answer.  0.07. What is the ratio of the Emissions (1000 metric ton of CO2 equivalent) of 2000 in Slovenia to that in South Africa?
Keep it short and to the point. 0.06. What is the ratio of the Emissions (1000 metric ton of CO2 equivalent) in 2005 in Slovenia to that in South Africa?
Provide a succinct answer. 0.06. What is the ratio of the Emissions (1000 metric ton of CO2 equivalent) of 2008 in Slovenia to that in South Africa?
Make the answer very short. 0.05. What is the ratio of the Emissions (1000 metric ton of CO2 equivalent) in 1990 in Slovenia to that in Spain?
Keep it short and to the point. 0.08. What is the ratio of the Emissions (1000 metric ton of CO2 equivalent) of 2000 in Slovenia to that in Spain?
Provide a short and direct response. 0.06. What is the ratio of the Emissions (1000 metric ton of CO2 equivalent) in 2005 in Slovenia to that in Spain?
Give a very brief answer. 0.05. What is the ratio of the Emissions (1000 metric ton of CO2 equivalent) of 2008 in Slovenia to that in Spain?
Your answer should be very brief. 0.05. What is the ratio of the Emissions (1000 metric ton of CO2 equivalent) in 1990 in Slovenia to that in Sri Lanka?
Your answer should be very brief. 0.17. What is the ratio of the Emissions (1000 metric ton of CO2 equivalent) in 2000 in Slovenia to that in Sri Lanka?
Make the answer very short. 0.18. What is the ratio of the Emissions (1000 metric ton of CO2 equivalent) of 2005 in Slovenia to that in Sri Lanka?
Make the answer very short. 0.17. What is the ratio of the Emissions (1000 metric ton of CO2 equivalent) in 2008 in Slovenia to that in Sri Lanka?
Keep it short and to the point. 0.14. What is the ratio of the Emissions (1000 metric ton of CO2 equivalent) in 1990 in Slovenia to that in Sudan?
Offer a terse response. 0.04. What is the ratio of the Emissions (1000 metric ton of CO2 equivalent) in 2000 in Slovenia to that in Sudan?
Ensure brevity in your answer.  0.02. What is the ratio of the Emissions (1000 metric ton of CO2 equivalent) of 2005 in Slovenia to that in Sudan?
Your answer should be compact. 0.02. What is the ratio of the Emissions (1000 metric ton of CO2 equivalent) in 2008 in Slovenia to that in Sudan?
Keep it short and to the point. 0.01. What is the ratio of the Emissions (1000 metric ton of CO2 equivalent) of 1990 in South Africa to that in Spain?
Give a very brief answer. 1.08. What is the ratio of the Emissions (1000 metric ton of CO2 equivalent) of 2000 in South Africa to that in Spain?
Keep it short and to the point. 0.94. What is the ratio of the Emissions (1000 metric ton of CO2 equivalent) in 2005 in South Africa to that in Spain?
Provide a short and direct response. 0.97. What is the ratio of the Emissions (1000 metric ton of CO2 equivalent) of 2008 in South Africa to that in Spain?
Your response must be concise. 1. What is the ratio of the Emissions (1000 metric ton of CO2 equivalent) of 1990 in South Africa to that in Sri Lanka?
Give a very brief answer. 2.23. What is the ratio of the Emissions (1000 metric ton of CO2 equivalent) in 2000 in South Africa to that in Sri Lanka?
Your answer should be very brief. 3.06. What is the ratio of the Emissions (1000 metric ton of CO2 equivalent) in 2005 in South Africa to that in Sri Lanka?
Give a very brief answer. 3.01. What is the ratio of the Emissions (1000 metric ton of CO2 equivalent) of 2008 in South Africa to that in Sri Lanka?
Ensure brevity in your answer.  2.67. What is the ratio of the Emissions (1000 metric ton of CO2 equivalent) in 1990 in South Africa to that in Sudan?
Provide a short and direct response. 0.49. What is the ratio of the Emissions (1000 metric ton of CO2 equivalent) of 2000 in South Africa to that in Sudan?
Offer a terse response. 0.35. What is the ratio of the Emissions (1000 metric ton of CO2 equivalent) of 2005 in South Africa to that in Sudan?
Make the answer very short. 0.34. What is the ratio of the Emissions (1000 metric ton of CO2 equivalent) of 2008 in South Africa to that in Sudan?
Give a very brief answer. 0.23. What is the ratio of the Emissions (1000 metric ton of CO2 equivalent) of 1990 in Spain to that in Sri Lanka?
Provide a succinct answer. 2.06. What is the ratio of the Emissions (1000 metric ton of CO2 equivalent) in 2000 in Spain to that in Sri Lanka?
Offer a terse response. 3.25. What is the ratio of the Emissions (1000 metric ton of CO2 equivalent) of 2005 in Spain to that in Sri Lanka?
Offer a terse response. 3.1. What is the ratio of the Emissions (1000 metric ton of CO2 equivalent) of 2008 in Spain to that in Sri Lanka?
Offer a terse response. 2.66. What is the ratio of the Emissions (1000 metric ton of CO2 equivalent) in 1990 in Spain to that in Sudan?
Your response must be concise. 0.45. What is the ratio of the Emissions (1000 metric ton of CO2 equivalent) of 2000 in Spain to that in Sudan?
Make the answer very short. 0.37. What is the ratio of the Emissions (1000 metric ton of CO2 equivalent) in 2005 in Spain to that in Sudan?
Your response must be concise. 0.35. What is the ratio of the Emissions (1000 metric ton of CO2 equivalent) in 2008 in Spain to that in Sudan?
Offer a terse response. 0.23. What is the ratio of the Emissions (1000 metric ton of CO2 equivalent) in 1990 in Sri Lanka to that in Sudan?
Offer a terse response. 0.22. What is the ratio of the Emissions (1000 metric ton of CO2 equivalent) in 2000 in Sri Lanka to that in Sudan?
Offer a very short reply. 0.12. What is the ratio of the Emissions (1000 metric ton of CO2 equivalent) of 2005 in Sri Lanka to that in Sudan?
Offer a terse response. 0.11. What is the ratio of the Emissions (1000 metric ton of CO2 equivalent) of 2008 in Sri Lanka to that in Sudan?
Ensure brevity in your answer.  0.09. What is the difference between the highest and the second highest Emissions (1000 metric ton of CO2 equivalent) in 1990?
Provide a succinct answer. 2.00e+04. What is the difference between the highest and the second highest Emissions (1000 metric ton of CO2 equivalent) of 2000?
Provide a succinct answer. 3.34e+04. What is the difference between the highest and the second highest Emissions (1000 metric ton of CO2 equivalent) of 2005?
Provide a succinct answer. 3.83e+04. What is the difference between the highest and the second highest Emissions (1000 metric ton of CO2 equivalent) in 2008?
Give a very brief answer. 6.84e+04. What is the difference between the highest and the lowest Emissions (1000 metric ton of CO2 equivalent) of 1990?
Provide a short and direct response. 3.77e+04. What is the difference between the highest and the lowest Emissions (1000 metric ton of CO2 equivalent) of 2000?
Ensure brevity in your answer.  5.23e+04. What is the difference between the highest and the lowest Emissions (1000 metric ton of CO2 equivalent) of 2005?
Your response must be concise. 5.78e+04. What is the difference between the highest and the lowest Emissions (1000 metric ton of CO2 equivalent) in 2008?
Your response must be concise. 8.77e+04. 